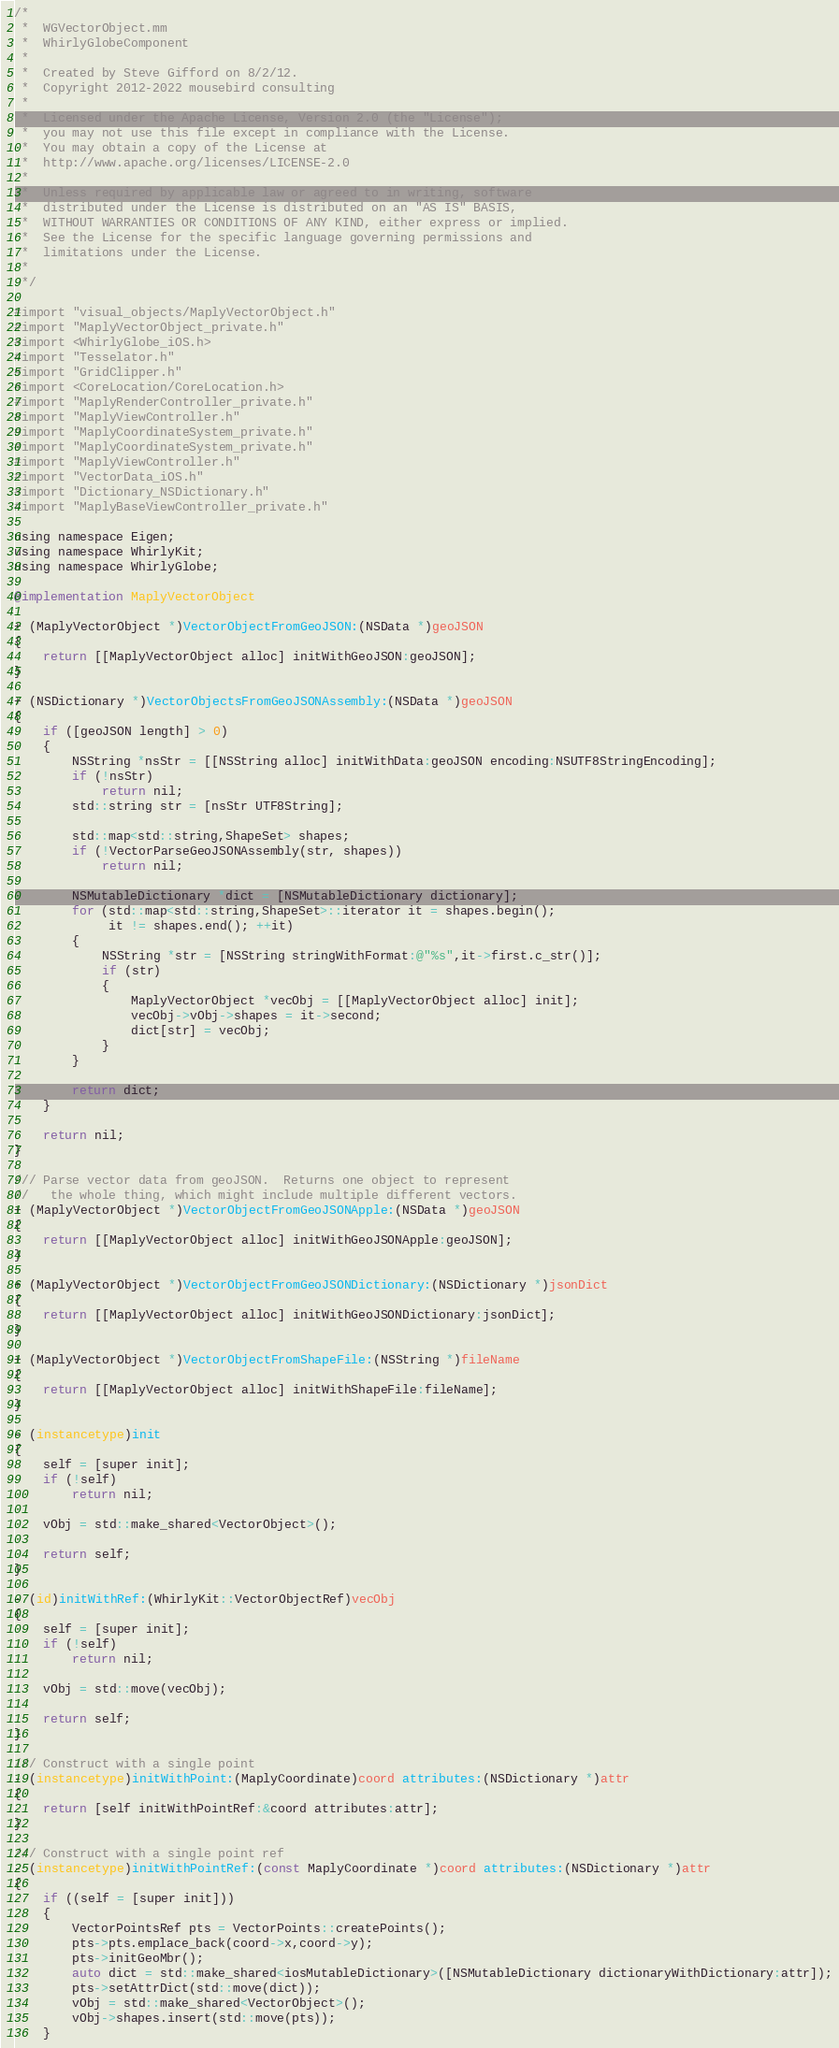<code> <loc_0><loc_0><loc_500><loc_500><_ObjectiveC_>/*
 *  WGVectorObject.mm
 *  WhirlyGlobeComponent
 *
 *  Created by Steve Gifford on 8/2/12.
 *  Copyright 2012-2022 mousebird consulting
 *
 *  Licensed under the Apache License, Version 2.0 (the "License");
 *  you may not use this file except in compliance with the License.
 *  You may obtain a copy of the License at
 *  http://www.apache.org/licenses/LICENSE-2.0
 *
 *  Unless required by applicable law or agreed to in writing, software
 *  distributed under the License is distributed on an "AS IS" BASIS,
 *  WITHOUT WARRANTIES OR CONDITIONS OF ANY KIND, either express or implied.
 *  See the License for the specific language governing permissions and
 *  limitations under the License.
 *
 */

#import "visual_objects/MaplyVectorObject.h"
#import "MaplyVectorObject_private.h"
#import <WhirlyGlobe_iOS.h>
#import "Tesselator.h"
#import "GridClipper.h"
#import <CoreLocation/CoreLocation.h>
#import "MaplyRenderController_private.h"
#import "MaplyViewController.h"
#import "MaplyCoordinateSystem_private.h"
#import "MaplyCoordinateSystem_private.h"
#import "MaplyViewController.h"
#import "VectorData_iOS.h"
#import "Dictionary_NSDictionary.h"
#import "MaplyBaseViewController_private.h"

using namespace Eigen;
using namespace WhirlyKit;
using namespace WhirlyGlobe;

@implementation MaplyVectorObject

+ (MaplyVectorObject *)VectorObjectFromGeoJSON:(NSData *)geoJSON
{
	return [[MaplyVectorObject alloc] initWithGeoJSON:geoJSON];
}

+ (NSDictionary *)VectorObjectsFromGeoJSONAssembly:(NSData *)geoJSON
{
    if ([geoJSON length] > 0)
    {
        NSString *nsStr = [[NSString alloc] initWithData:geoJSON encoding:NSUTF8StringEncoding];
        if (!nsStr)
            return nil;
        std::string str = [nsStr UTF8String];
        
        std::map<std::string,ShapeSet> shapes;
        if (!VectorParseGeoJSONAssembly(str, shapes))
            return nil;
        
        NSMutableDictionary *dict = [NSMutableDictionary dictionary];
        for (std::map<std::string,ShapeSet>::iterator it = shapes.begin();
             it != shapes.end(); ++it)
        {
            NSString *str = [NSString stringWithFormat:@"%s",it->first.c_str()];
            if (str)
            {
                MaplyVectorObject *vecObj = [[MaplyVectorObject alloc] init];
                vecObj->vObj->shapes = it->second;
                dict[str] = vecObj;
            }
        }
        
        return dict;
    }
    
    return nil;
}

/// Parse vector data from geoJSON.  Returns one object to represent
//   the whole thing, which might include multiple different vectors.
+ (MaplyVectorObject *)VectorObjectFromGeoJSONApple:(NSData *)geoJSON
{
	return [[MaplyVectorObject alloc] initWithGeoJSONApple:geoJSON];
}

+ (MaplyVectorObject *)VectorObjectFromGeoJSONDictionary:(NSDictionary *)jsonDict
{
	return [[MaplyVectorObject alloc] initWithGeoJSONDictionary:jsonDict];
}

+ (MaplyVectorObject *)VectorObjectFromShapeFile:(NSString *)fileName
{
	return [[MaplyVectorObject alloc] initWithShapeFile:fileName];
}

- (instancetype)init
{
    self = [super init];
    if (!self)
        return nil;
    
    vObj = std::make_shared<VectorObject>();
    
    return self;
}

- (id)initWithRef:(WhirlyKit::VectorObjectRef)vecObj
{
    self = [super init];
    if (!self)
        return nil;

    vObj = std::move(vecObj);
    
    return self;
}

/// Construct with a single point
- (instancetype)initWithPoint:(MaplyCoordinate)coord attributes:(NSDictionary *)attr
{
	return [self initWithPointRef:&coord attributes:attr];
}

/// Construct with a single point ref
- (instancetype)initWithPointRef:(const MaplyCoordinate *)coord attributes:(NSDictionary *)attr
{
    if ((self = [super init]))
    {
        VectorPointsRef pts = VectorPoints::createPoints();
        pts->pts.emplace_back(coord->x,coord->y);
        pts->initGeoMbr();
        auto dict = std::make_shared<iosMutableDictionary>([NSMutableDictionary dictionaryWithDictionary:attr]);
        pts->setAttrDict(std::move(dict));
        vObj = std::make_shared<VectorObject>();
        vObj->shapes.insert(std::move(pts));
    }</code> 